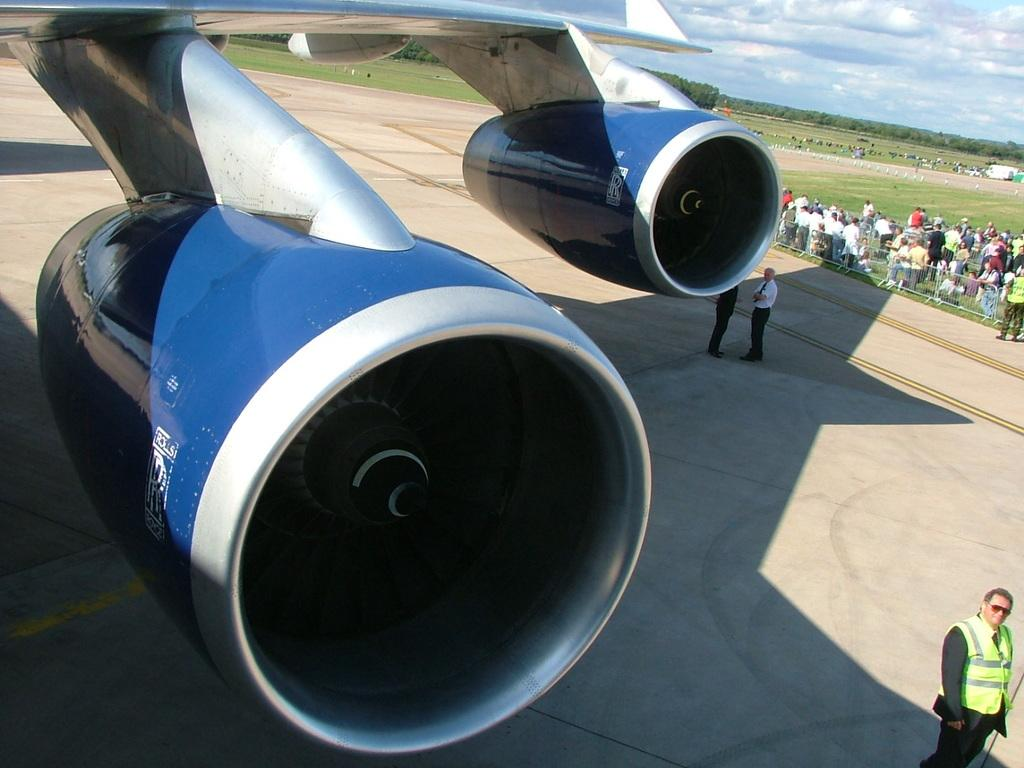What is the main subject of the image? The main subject of the image is an airplane. What else can be seen in the image besides the airplane? There is a path visible in the image, as well as people, green grass, trees, and the sky in the background. How many children are sitting on the cactus in the image? There is no cactus or children present in the image. 